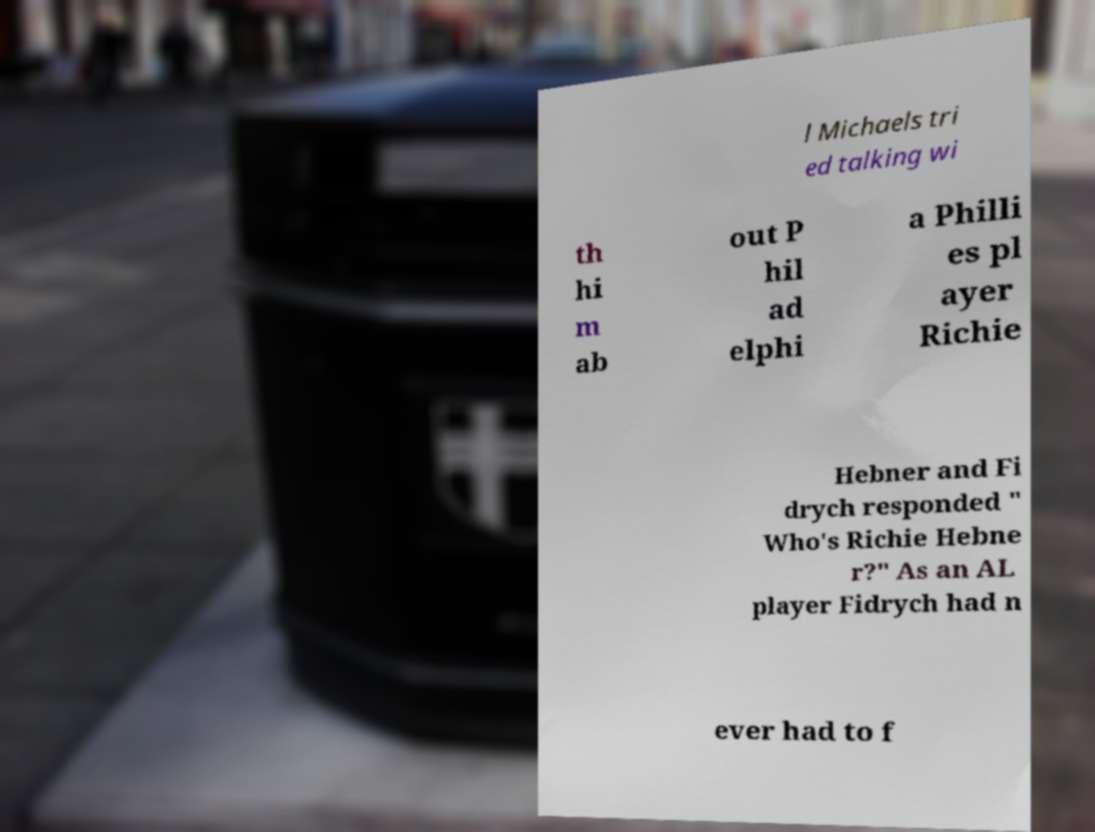There's text embedded in this image that I need extracted. Can you transcribe it verbatim? l Michaels tri ed talking wi th hi m ab out P hil ad elphi a Philli es pl ayer Richie Hebner and Fi drych responded " Who's Richie Hebne r?" As an AL player Fidrych had n ever had to f 